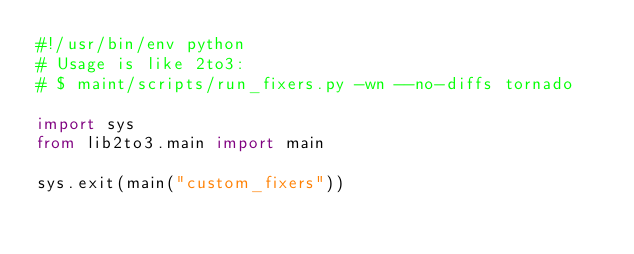Convert code to text. <code><loc_0><loc_0><loc_500><loc_500><_Python_>#!/usr/bin/env python
# Usage is like 2to3:
# $ maint/scripts/run_fixers.py -wn --no-diffs tornado

import sys
from lib2to3.main import main

sys.exit(main("custom_fixers"))
</code> 